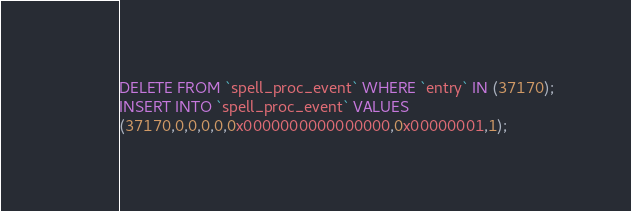<code> <loc_0><loc_0><loc_500><loc_500><_SQL_>DELETE FROM `spell_proc_event` WHERE `entry` IN (37170);
INSERT INTO `spell_proc_event` VALUES
(37170,0,0,0,0,0x0000000000000000,0x00000001,1);
</code> 